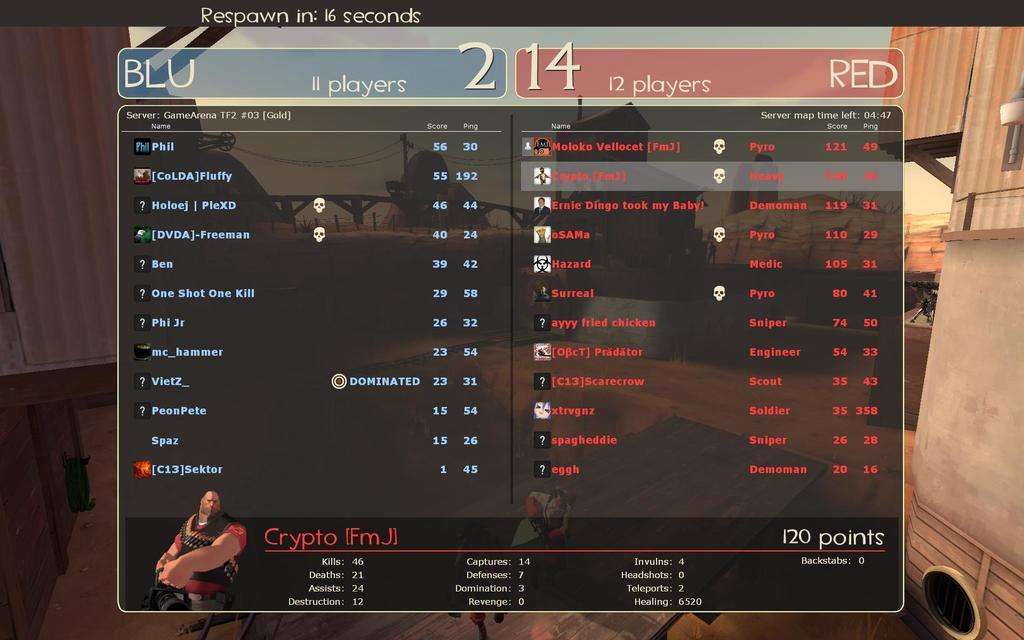<image>
Render a clear and concise summary of the photo. A game screen displays scores of 2 and 14 for the Blu and Red teams respectively. 